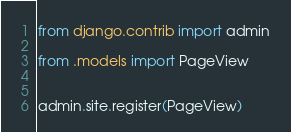<code> <loc_0><loc_0><loc_500><loc_500><_Python_>from django.contrib import admin

from .models import PageView


admin.site.register(PageView)</code> 